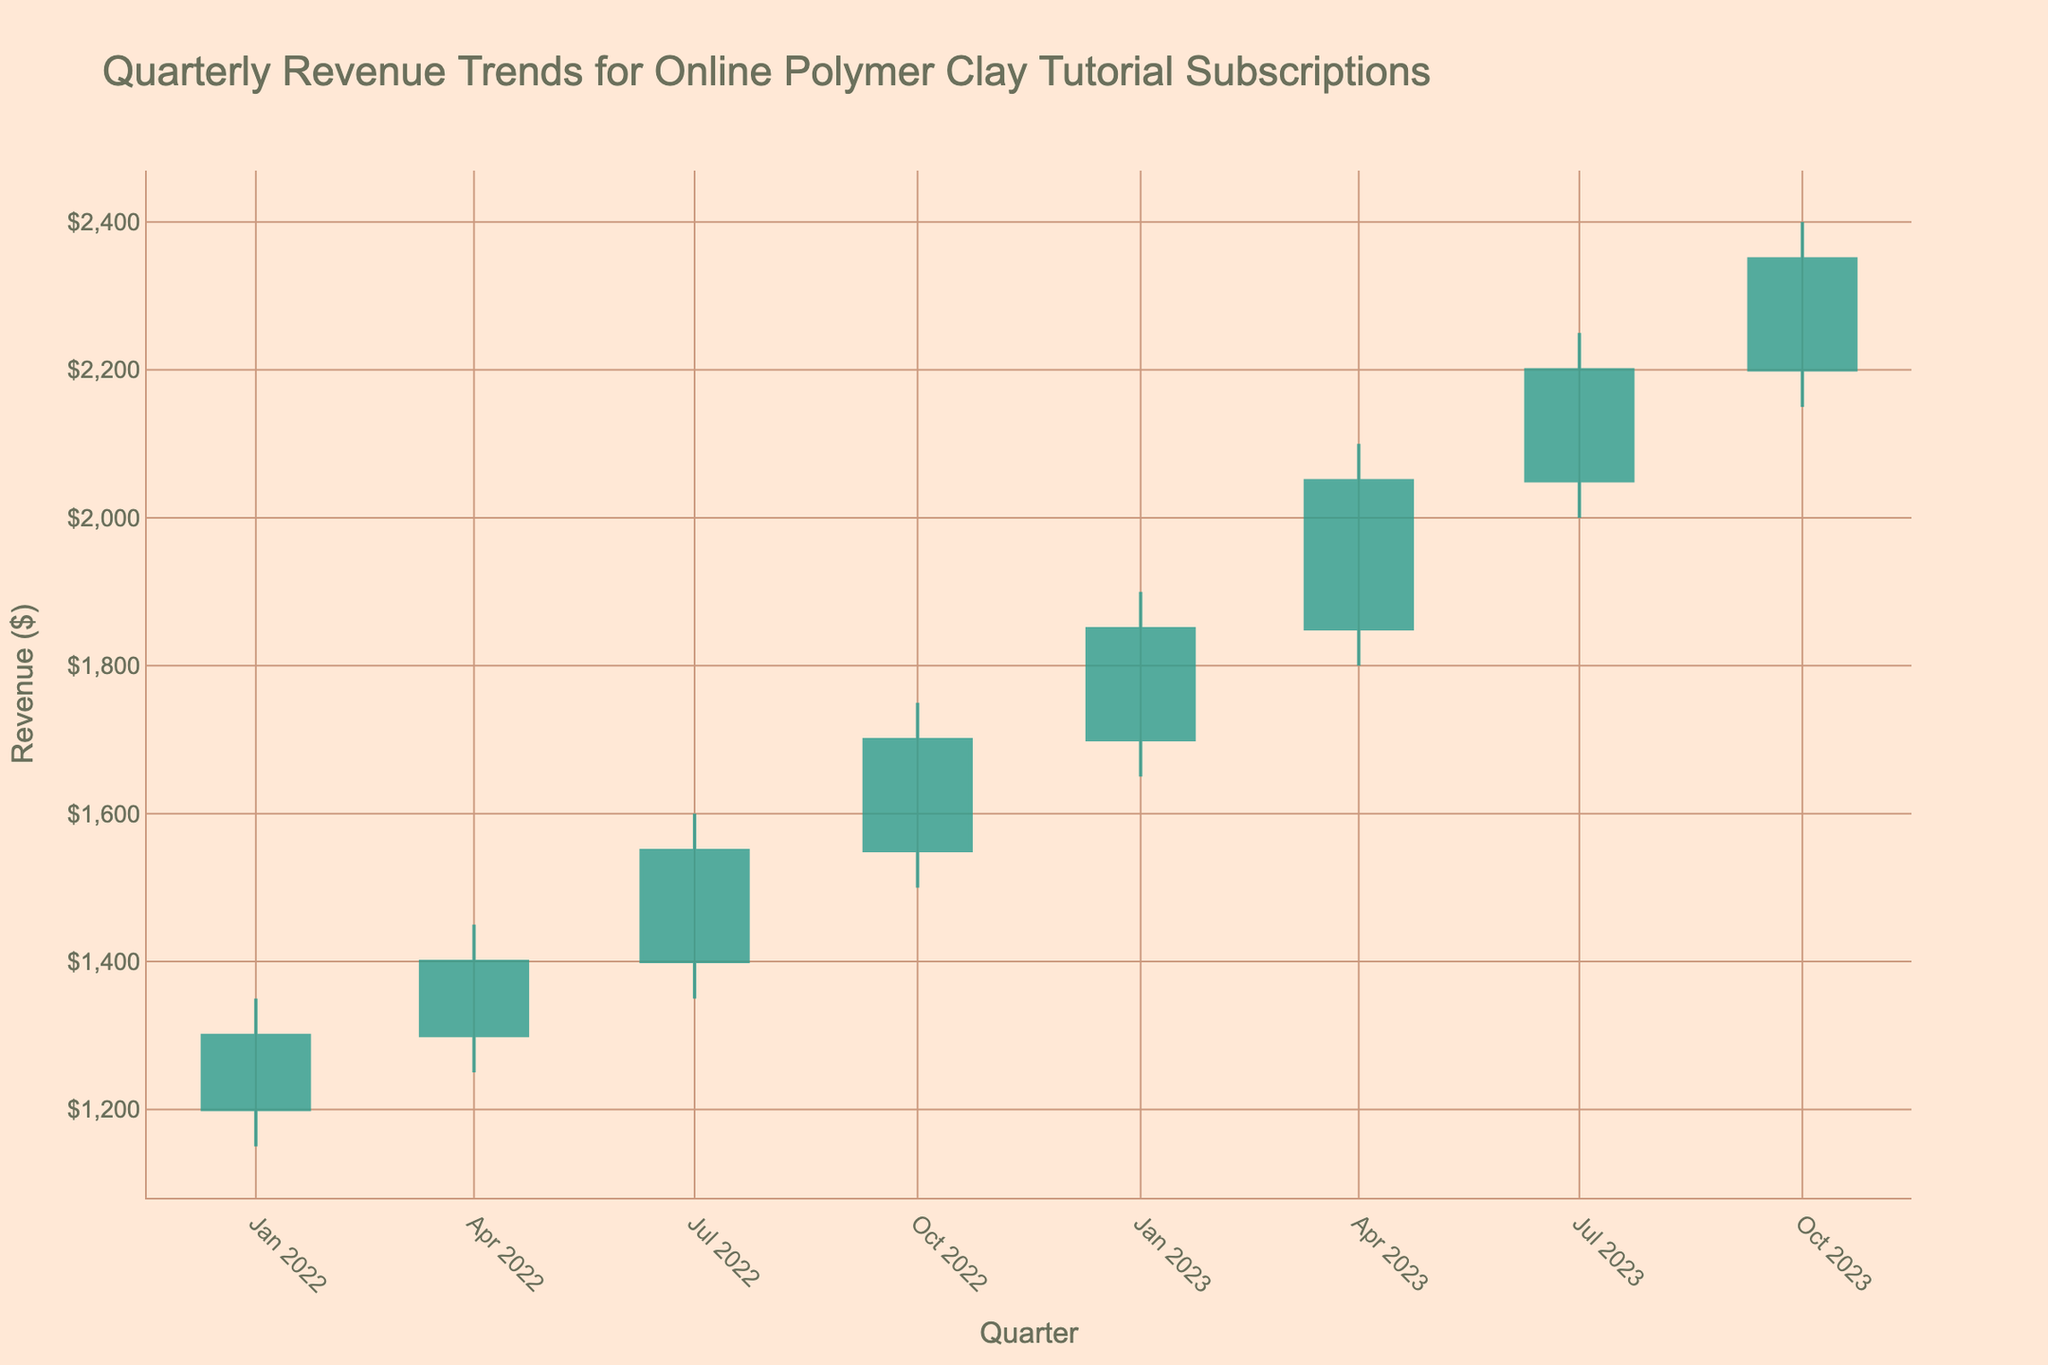What is the title of the figure? The title is displayed at the top of the figure, and it states "Quarterly Revenue Trends for Online Polymer Clay Tutorial Subscriptions"
Answer: Quarterly Revenue Trends for Online Polymer Clay Tutorial Subscriptions How many data points are represented in the figure? The figure visually represents data points for each quarter over two years. Since we have quarterly data for 2022 and 2023, there are 8 data points in total.
Answer: 8 What was the highest revenue recorded in any quarter? The highest revenue recorded is shown as the highest "High" value in the candlestick chart. In 2023-Q4, the highest revenue is $2400.
Answer: $2400 Which quarter experienced the largest increase in closing revenue compared to the previous quarter? To determine this, we need to compare the closing revenues between consecutive quarters. The difference between each subsequent closing revenue is as follows: 
- Q2-Q1: 1400-1300 = 100
- Q3-Q2: 1550-1400 = 150
- Q4-Q3: 1700-1550 = 150
- Q1-Q4 (2023-2022): 1850-1700 = 150
- Q2-Q1: 2050-1850 = 200
- Q3-Q2: 2200-2050 = 150
- Q4-Q3: 2350-2200 = 150
The largest increase of 200 occurred from 2023-Q1 to 2023-Q2.
Answer: 2023-Q2 What is the average closing revenue for the entire period? To find the average closing revenue, sum up all closing values and divide by the number of data points. The closing values are 1300, 1400, 1550, 1700, 1850, 2050, 2200, 2350. The sum is 14400, and the average is 14400 / 8 = 1800.
Answer: 1800 Which quarter had the smallest range between the highest and lowest revenue values? To find the quarter with the smallest range, calculate the range (high - low) for each quarter:
- 2022-Q1: 1350 - 1150 = 200
- 2022-Q2: 1450 - 1250 = 200
- 2022-Q3: 1600 - 1350 = 250
- 2022-Q4: 1750 - 1500 = 250
- 2023-Q1: 1900 - 1650 = 250
- 2023-Q2: 2100 - 1800 = 300
- 2023-Q3: 2250 - 2000 = 250
- 2023-Q4: 2400 - 2150 = 250
The smallest range is 200, which occurred in 2022-Q1 and 2022-Q2.
Answer: 2022-Q1 and 2022-Q2 Which quarter had the highest opening revenue? The highest opening revenue is the maximum value in the "Open" column. The highest opening revenue of $2200 is recorded in 2023-Q4.
Answer: 2023-Q4 During which quarters did the closing revenue exceed the opening revenue? To determine this, compare the closing revenue to the opening revenue for each quarter:
- 2022-Q1: 1300 > 1200
- 2022-Q2: 1400 > 1300
- 2022-Q3: 1550 > 1400
- 2022-Q4: 1700 > 1550
- 2023-Q1: 1850 > 1700
- 2023-Q2: 2050 > 1850
- 2023-Q3: 2200 > 2050
- 2023-Q4: 2350 > 2200
In all quarters, the closing revenue exceeded the opening revenue.
Answer: All quarters What was the lowest opening revenue recorded during this period? To find the lowest opening revenue, we look at the minimum value in the "Open" column, which is $1200 in 2022-Q1.
Answer: $1200 